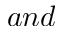<formula> <loc_0><loc_0><loc_500><loc_500>a n d</formula> 